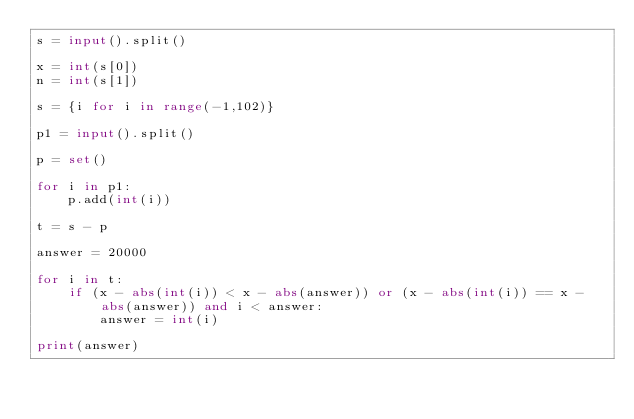<code> <loc_0><loc_0><loc_500><loc_500><_Python_>s = input().split()

x = int(s[0])
n = int(s[1])

s = {i for i in range(-1,102)}

p1 = input().split()

p = set()

for i in p1:
    p.add(int(i))

t = s - p

answer = 20000

for i in t:
    if (x - abs(int(i)) < x - abs(answer)) or (x - abs(int(i)) == x - abs(answer)) and i < answer:
        answer = int(i)

print(answer)</code> 